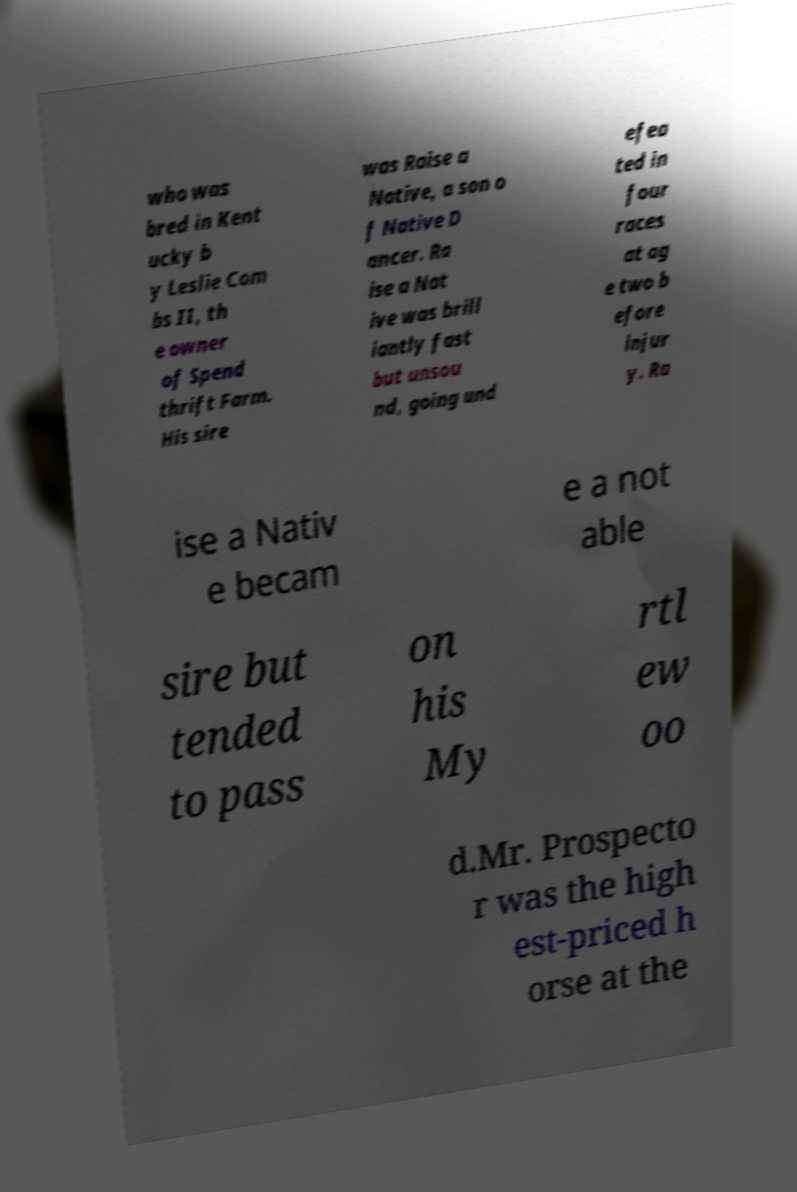I need the written content from this picture converted into text. Can you do that? who was bred in Kent ucky b y Leslie Com bs II, th e owner of Spend thrift Farm. His sire was Raise a Native, a son o f Native D ancer. Ra ise a Nat ive was brill iantly fast but unsou nd, going und efea ted in four races at ag e two b efore injur y. Ra ise a Nativ e becam e a not able sire but tended to pass on his My rtl ew oo d.Mr. Prospecto r was the high est-priced h orse at the 